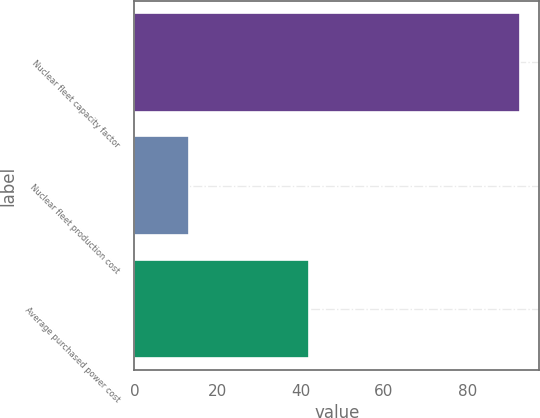<chart> <loc_0><loc_0><loc_500><loc_500><bar_chart><fcel>Nuclear fleet capacity factor<fcel>Nuclear fleet production cost<fcel>Average purchased power cost<nl><fcel>92.7<fcel>13<fcel>41.85<nl></chart> 